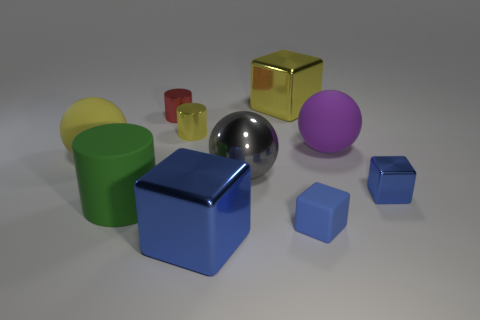How many things are either big objects left of the tiny red metallic thing or big objects?
Your response must be concise. 6. How many yellow things are either large shiny spheres or metallic cylinders?
Provide a short and direct response. 1. How many other objects are the same color as the tiny rubber block?
Your answer should be very brief. 2. Is the number of blue blocks that are on the left side of the big green object less than the number of purple rubber objects?
Offer a terse response. Yes. What is the color of the large block behind the cylinder that is in front of the rubber thing that is left of the green matte cylinder?
Your answer should be very brief. Yellow. What is the size of the yellow thing that is the same shape as the gray object?
Ensure brevity in your answer.  Large. Is the number of matte cylinders in front of the tiny rubber thing less than the number of yellow metallic things behind the yellow cylinder?
Your answer should be compact. Yes. What is the shape of the rubber thing that is both on the right side of the small red thing and behind the blue matte thing?
Ensure brevity in your answer.  Sphere. What size is the gray thing that is the same material as the tiny red cylinder?
Make the answer very short. Large. Do the tiny metal block and the big cube left of the big gray shiny ball have the same color?
Your response must be concise. Yes. 